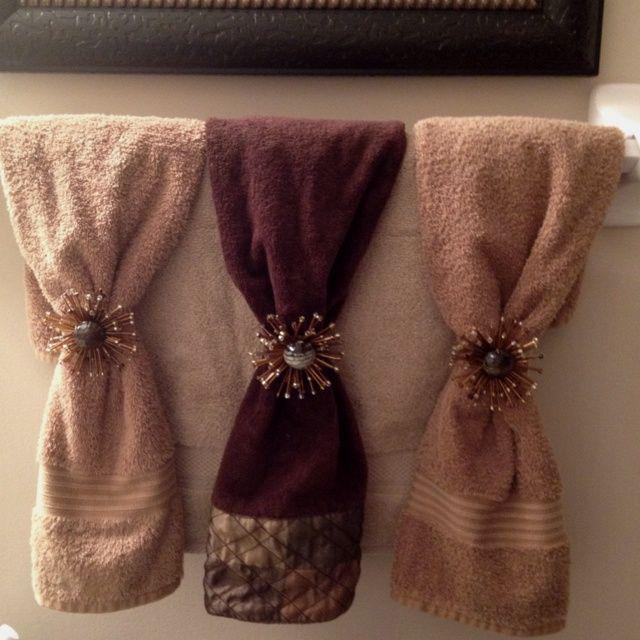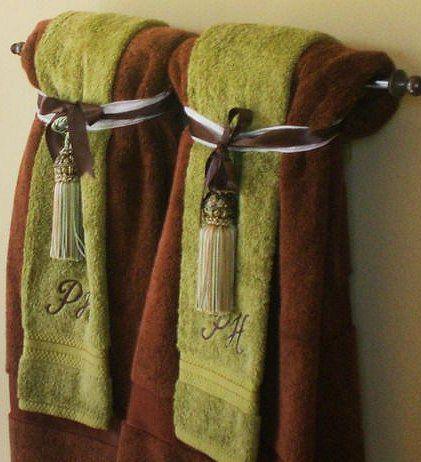The first image is the image on the left, the second image is the image on the right. Assess this claim about the two images: "Towels are hung on the wall under pictures.". Correct or not? Answer yes or no. No. 